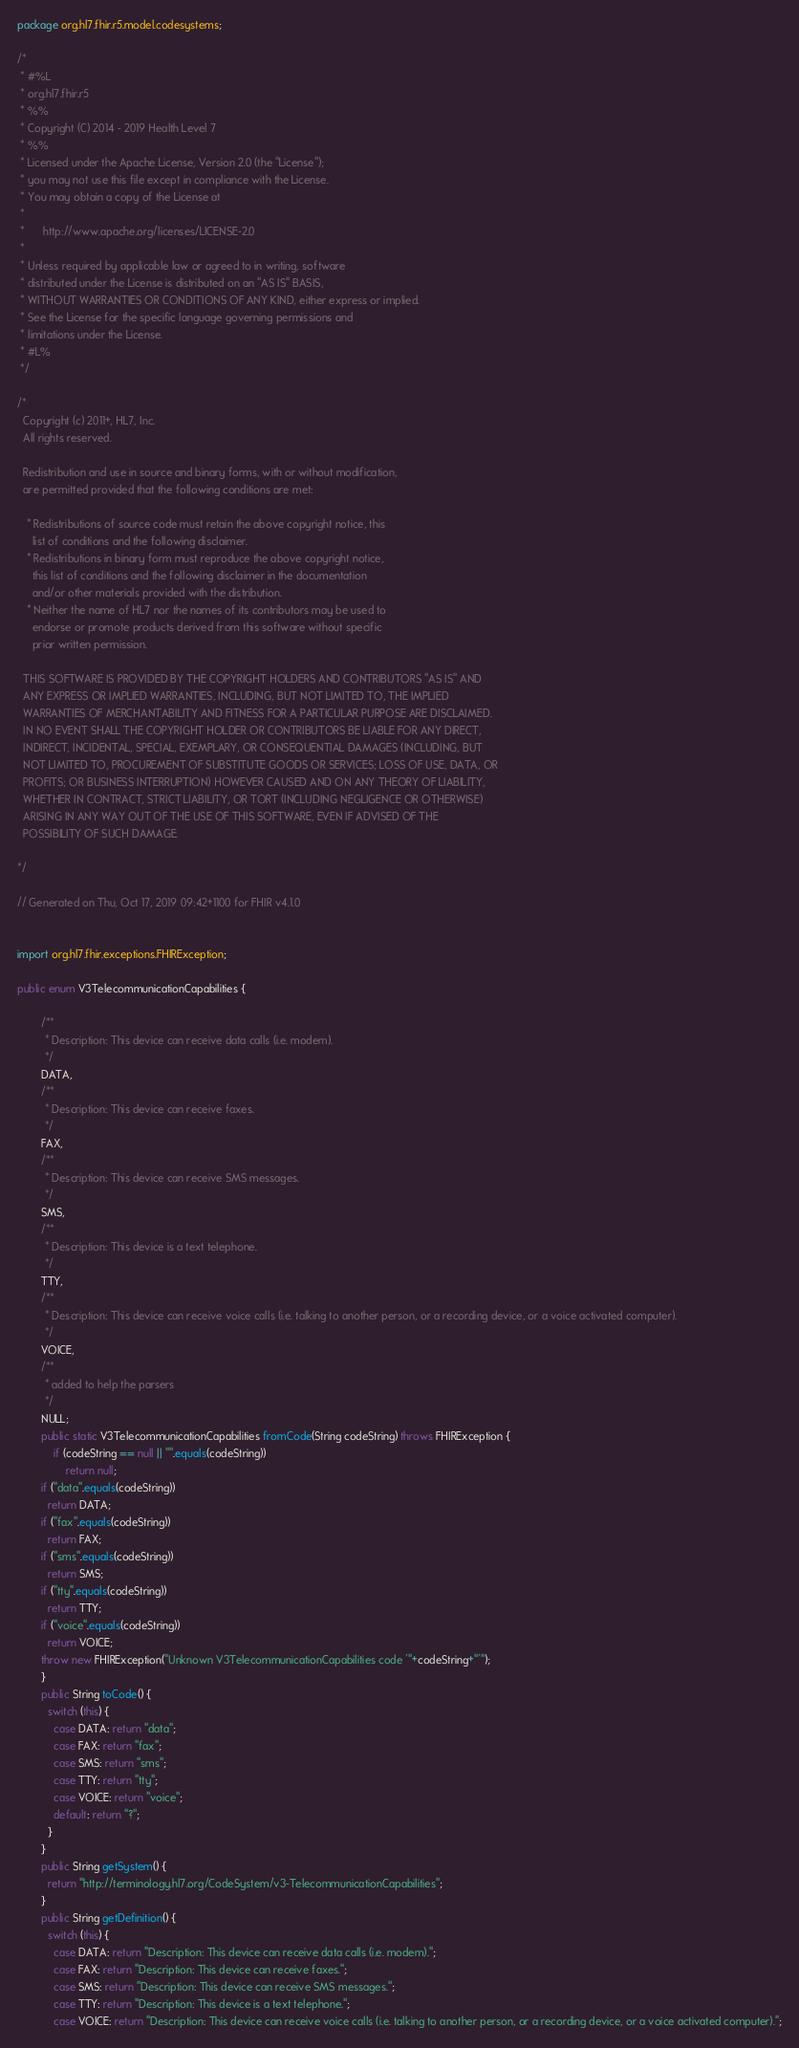Convert code to text. <code><loc_0><loc_0><loc_500><loc_500><_Java_>package org.hl7.fhir.r5.model.codesystems;

/*
 * #%L
 * org.hl7.fhir.r5
 * %%
 * Copyright (C) 2014 - 2019 Health Level 7
 * %%
 * Licensed under the Apache License, Version 2.0 (the "License");
 * you may not use this file except in compliance with the License.
 * You may obtain a copy of the License at
 * 
 *      http://www.apache.org/licenses/LICENSE-2.0
 * 
 * Unless required by applicable law or agreed to in writing, software
 * distributed under the License is distributed on an "AS IS" BASIS,
 * WITHOUT WARRANTIES OR CONDITIONS OF ANY KIND, either express or implied.
 * See the License for the specific language governing permissions and
 * limitations under the License.
 * #L%
 */

/*
  Copyright (c) 2011+, HL7, Inc.
  All rights reserved.
  
  Redistribution and use in source and binary forms, with or without modification, 
  are permitted provided that the following conditions are met:
  
   * Redistributions of source code must retain the above copyright notice, this 
     list of conditions and the following disclaimer.
   * Redistributions in binary form must reproduce the above copyright notice, 
     this list of conditions and the following disclaimer in the documentation 
     and/or other materials provided with the distribution.
   * Neither the name of HL7 nor the names of its contributors may be used to 
     endorse or promote products derived from this software without specific 
     prior written permission.
  
  THIS SOFTWARE IS PROVIDED BY THE COPYRIGHT HOLDERS AND CONTRIBUTORS "AS IS" AND 
  ANY EXPRESS OR IMPLIED WARRANTIES, INCLUDING, BUT NOT LIMITED TO, THE IMPLIED 
  WARRANTIES OF MERCHANTABILITY AND FITNESS FOR A PARTICULAR PURPOSE ARE DISCLAIMED. 
  IN NO EVENT SHALL THE COPYRIGHT HOLDER OR CONTRIBUTORS BE LIABLE FOR ANY DIRECT, 
  INDIRECT, INCIDENTAL, SPECIAL, EXEMPLARY, OR CONSEQUENTIAL DAMAGES (INCLUDING, BUT 
  NOT LIMITED TO, PROCUREMENT OF SUBSTITUTE GOODS OR SERVICES; LOSS OF USE, DATA, OR 
  PROFITS; OR BUSINESS INTERRUPTION) HOWEVER CAUSED AND ON ANY THEORY OF LIABILITY, 
  WHETHER IN CONTRACT, STRICT LIABILITY, OR TORT (INCLUDING NEGLIGENCE OR OTHERWISE) 
  ARISING IN ANY WAY OUT OF THE USE OF THIS SOFTWARE, EVEN IF ADVISED OF THE 
  POSSIBILITY OF SUCH DAMAGE.
  
*/

// Generated on Thu, Oct 17, 2019 09:42+1100 for FHIR v4.1.0


import org.hl7.fhir.exceptions.FHIRException;

public enum V3TelecommunicationCapabilities {

        /**
         * Description: This device can receive data calls (i.e. modem).
         */
        DATA, 
        /**
         * Description: This device can receive faxes.
         */
        FAX, 
        /**
         * Description: This device can receive SMS messages.
         */
        SMS, 
        /**
         * Description: This device is a text telephone.
         */
        TTY, 
        /**
         * Description: This device can receive voice calls (i.e. talking to another person, or a recording device, or a voice activated computer).
         */
        VOICE, 
        /**
         * added to help the parsers
         */
        NULL;
        public static V3TelecommunicationCapabilities fromCode(String codeString) throws FHIRException {
            if (codeString == null || "".equals(codeString))
                return null;
        if ("data".equals(codeString))
          return DATA;
        if ("fax".equals(codeString))
          return FAX;
        if ("sms".equals(codeString))
          return SMS;
        if ("tty".equals(codeString))
          return TTY;
        if ("voice".equals(codeString))
          return VOICE;
        throw new FHIRException("Unknown V3TelecommunicationCapabilities code '"+codeString+"'");
        }
        public String toCode() {
          switch (this) {
            case DATA: return "data";
            case FAX: return "fax";
            case SMS: return "sms";
            case TTY: return "tty";
            case VOICE: return "voice";
            default: return "?";
          }
        }
        public String getSystem() {
          return "http://terminology.hl7.org/CodeSystem/v3-TelecommunicationCapabilities";
        }
        public String getDefinition() {
          switch (this) {
            case DATA: return "Description: This device can receive data calls (i.e. modem).";
            case FAX: return "Description: This device can receive faxes.";
            case SMS: return "Description: This device can receive SMS messages.";
            case TTY: return "Description: This device is a text telephone.";
            case VOICE: return "Description: This device can receive voice calls (i.e. talking to another person, or a recording device, or a voice activated computer).";</code> 